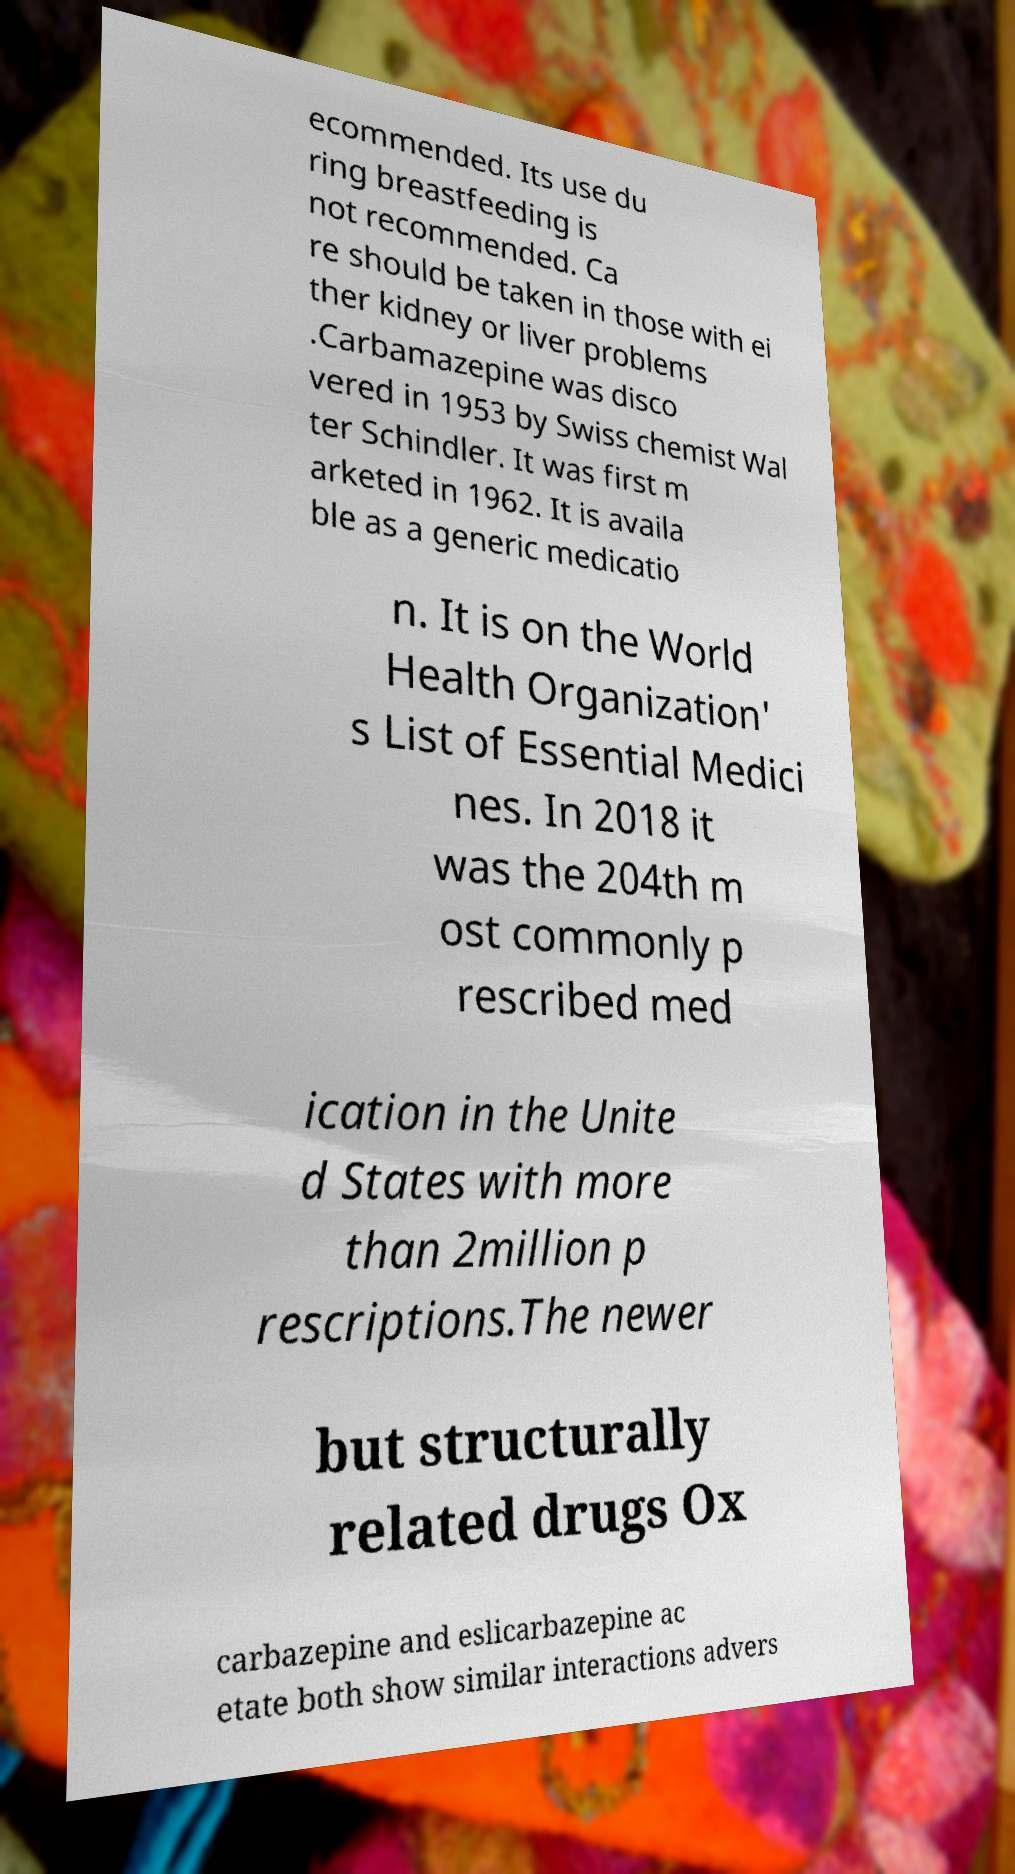Could you assist in decoding the text presented in this image and type it out clearly? ecommended. Its use du ring breastfeeding is not recommended. Ca re should be taken in those with ei ther kidney or liver problems .Carbamazepine was disco vered in 1953 by Swiss chemist Wal ter Schindler. It was first m arketed in 1962. It is availa ble as a generic medicatio n. It is on the World Health Organization' s List of Essential Medici nes. In 2018 it was the 204th m ost commonly p rescribed med ication in the Unite d States with more than 2million p rescriptions.The newer but structurally related drugs Ox carbazepine and eslicarbazepine ac etate both show similar interactions advers 